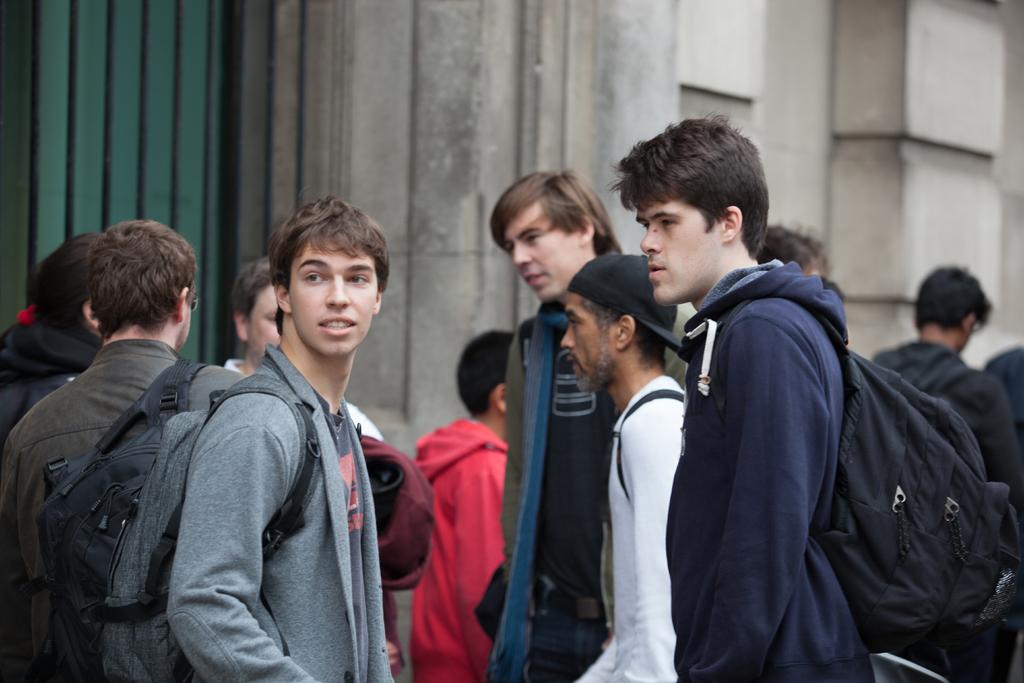Who or what is present in the image? There are people in the image. What are the people wearing? The people are wearing bags. What can be seen in the distance behind the people? There is a building in the background of the image. What type of maid can be seen cleaning the loaf in the image? There is no maid or loaf present in the image. Is there a notebook visible on the table in the image? There is no table or notebook mentioned in the provided facts, so we cannot determine if a notebook is present in the image. 